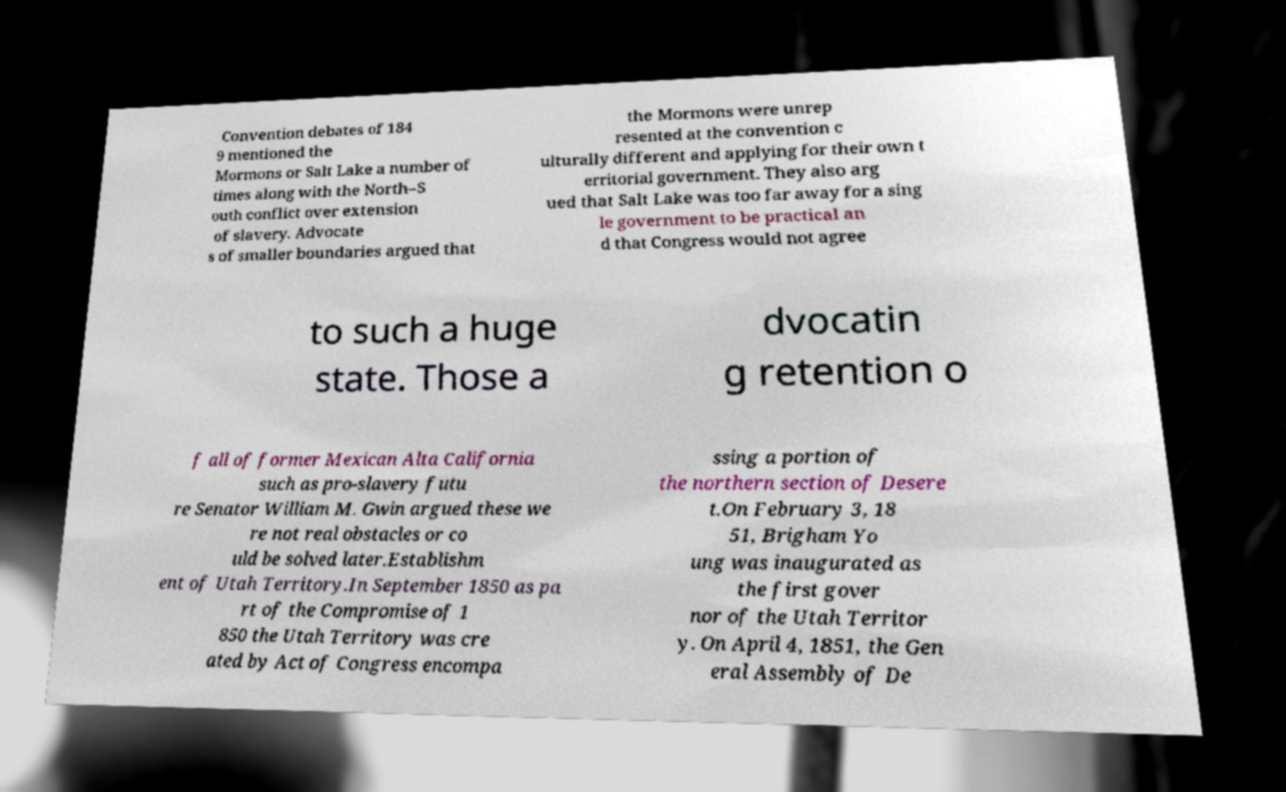Could you extract and type out the text from this image? Convention debates of 184 9 mentioned the Mormons or Salt Lake a number of times along with the North–S outh conflict over extension of slavery. Advocate s of smaller boundaries argued that the Mormons were unrep resented at the convention c ulturally different and applying for their own t erritorial government. They also arg ued that Salt Lake was too far away for a sing le government to be practical an d that Congress would not agree to such a huge state. Those a dvocatin g retention o f all of former Mexican Alta California such as pro-slavery futu re Senator William M. Gwin argued these we re not real obstacles or co uld be solved later.Establishm ent of Utah Territory.In September 1850 as pa rt of the Compromise of 1 850 the Utah Territory was cre ated by Act of Congress encompa ssing a portion of the northern section of Desere t.On February 3, 18 51, Brigham Yo ung was inaugurated as the first gover nor of the Utah Territor y. On April 4, 1851, the Gen eral Assembly of De 